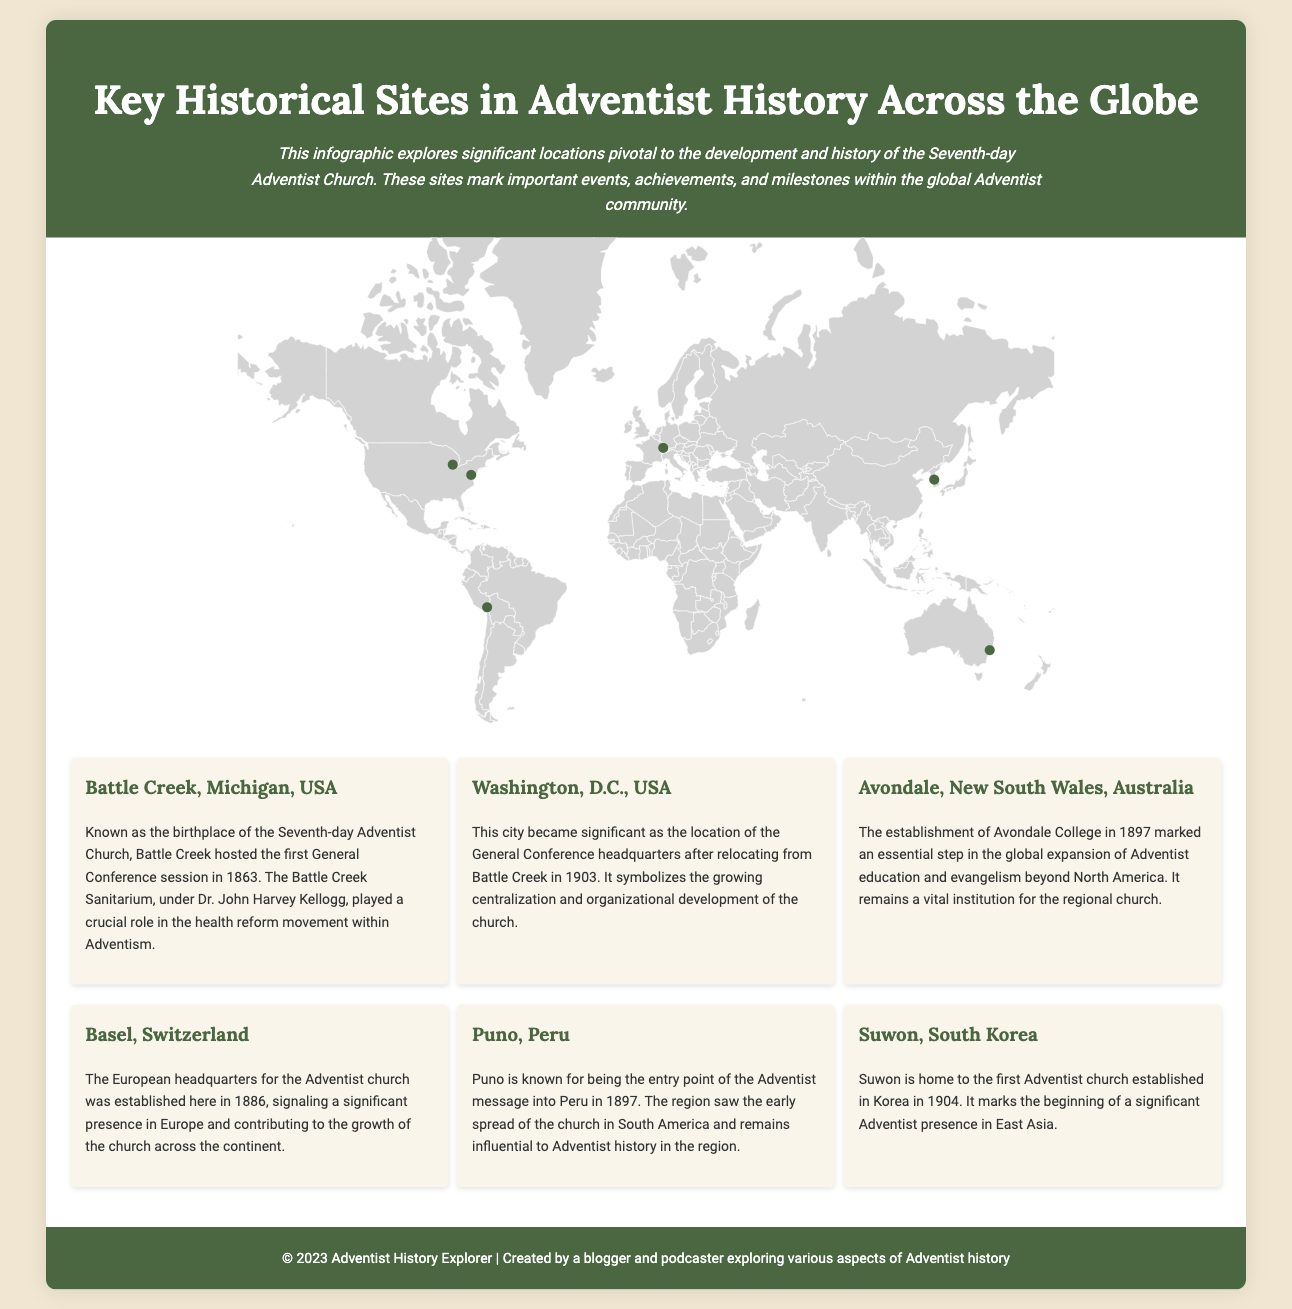What year was the first General Conference session held? The first General Conference session of the Seventh-day Adventist Church was held in 1863 in Battle Creek, Michigan.
Answer: 1863 Which location is described as the birthplace of the Seventh-day Adventist Church? The document states that Battle Creek, Michigan, is known as the birthplace of the Seventh-day Adventist Church.
Answer: Battle Creek, Michigan, USA In which city is the General Conference headquarters located? The document mentions that Washington, D.C., became significant as the location of the General Conference headquarters after its relocation from Battle Creek in 1903.
Answer: Washington, D.C., USA What significant event happened in Puno, Peru, in 1897? The text indicates that Puno is known for being the entry point of the Adventist message into Peru in 1897.
Answer: Entry of the Adventist message What institution was established in Avondale, Australia, in 1897? According to the document, Avondale College was established in 1897.
Answer: Avondale College How many significant historical sites are featured in the infographic? The infographic lists six key historical sites in Adventist history across the globe.
Answer: Six Which location marks the beginning of Adventist presence in East Asia? The document highlights Suwon, South Korea, as the site marking the beginning of Adventist presence in East Asia.
Answer: Suwon, South Korea What does the document primarily explore? The main focus of the document is to explore significant locations pivotal to the development and history of the Seventh-day Adventist Church.
Answer: Significant locations in Adventist history What is the background color of the footer in the document? The footer background color is the same as the header, which is #4a6741 (a dark green).
Answer: Dark green 